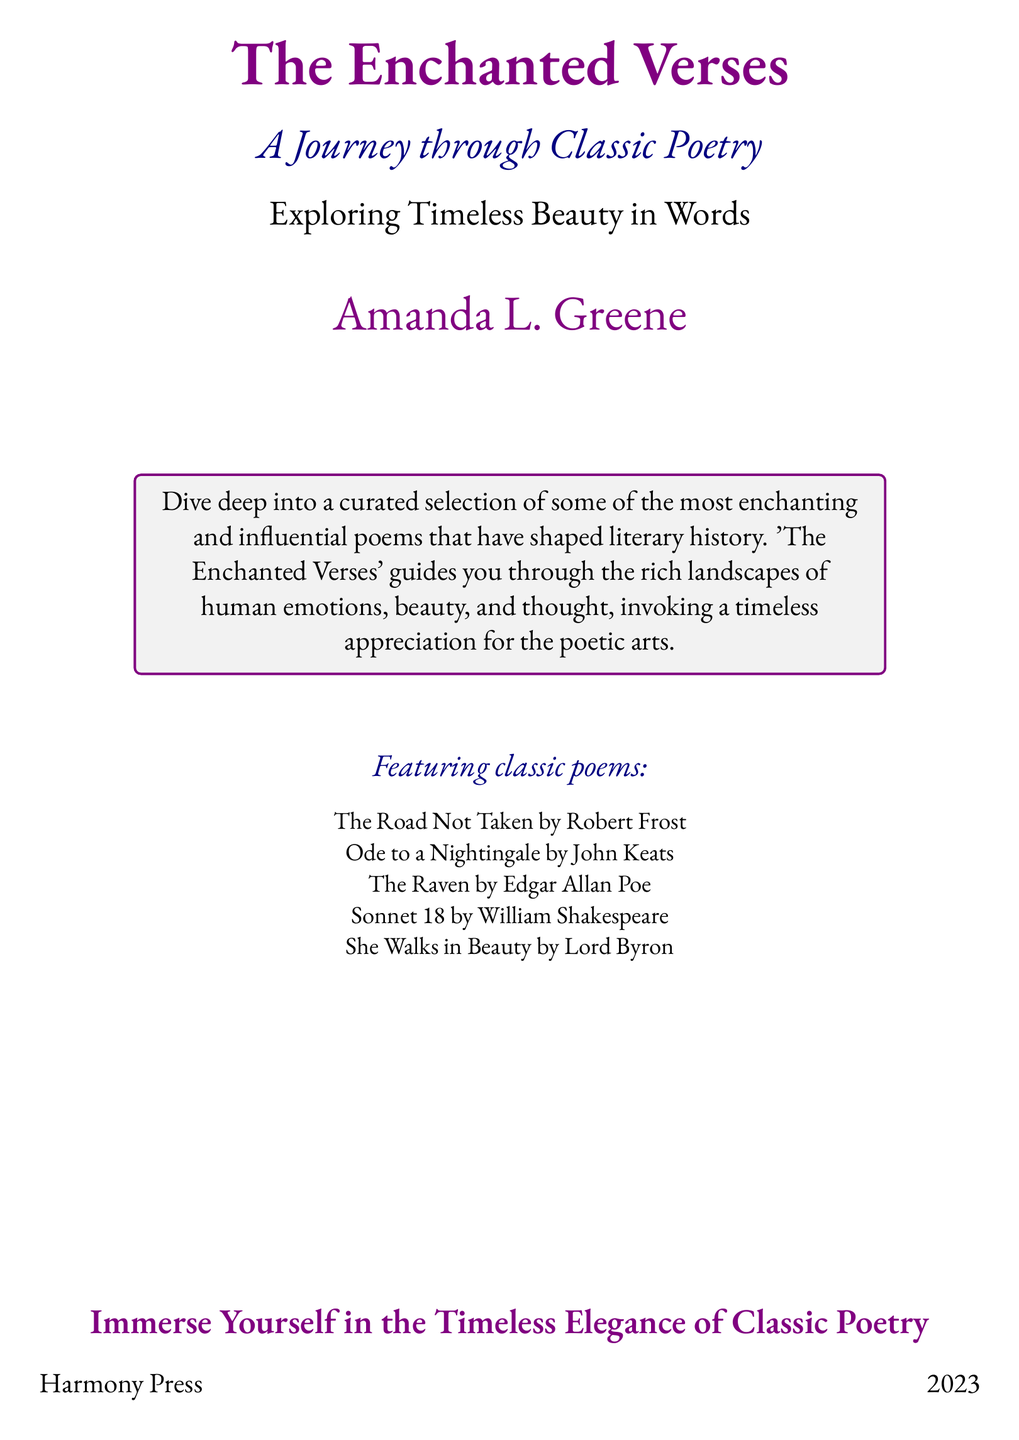What is the title of the book? The title of the book is prominently displayed at the top of the document in large font.
Answer: The Enchanted Verses Who is the author of the book? The author's name is located below the title and is in a slightly smaller font size.
Answer: Amanda L. Greene What year was the book published? The publication year is located near the bottom of the document.
Answer: 2023 What is the subtitle of the book? The subtitle provides context for the title and is positioned just below it.
Answer: A Journey through Classic Poetry Name one poem featured in the book. The featured poems are listed in a section specifically mentioned for that purpose.
Answer: The Road Not Taken What color is used for the title text? The title text color is specified at the beginning of the document.
Answer: Purple How many classic poems are mentioned? The number of poems can be counted in the featured section of the document.
Answer: Five What is the purpose of 'The Enchanted Verses'? The purpose is outlined in the box that describes the content of the book.
Answer: Exploring Timeless Beauty in Words What is the name of the publishing press? The name of the publishing press is mentioned at the bottom of the document.
Answer: Harmony Press 